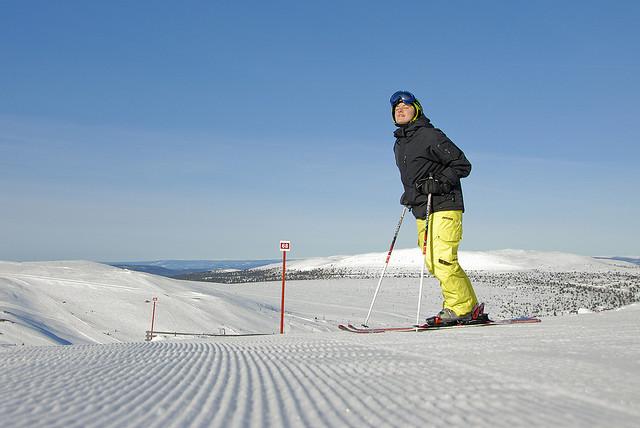What color are the persons pance?
Give a very brief answer. Yellow. What was recently groomed?
Keep it brief. Snow. What is on the ground?
Concise answer only. Snow. 